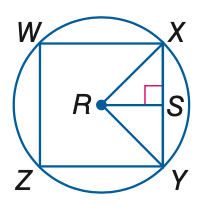Question: In the figure, square W X Y Z is inscribed in \odot R. Find the measure of a central angle.
Choices:
A. 45
B. 90
C. 180
D. 270
Answer with the letter. Answer: B 